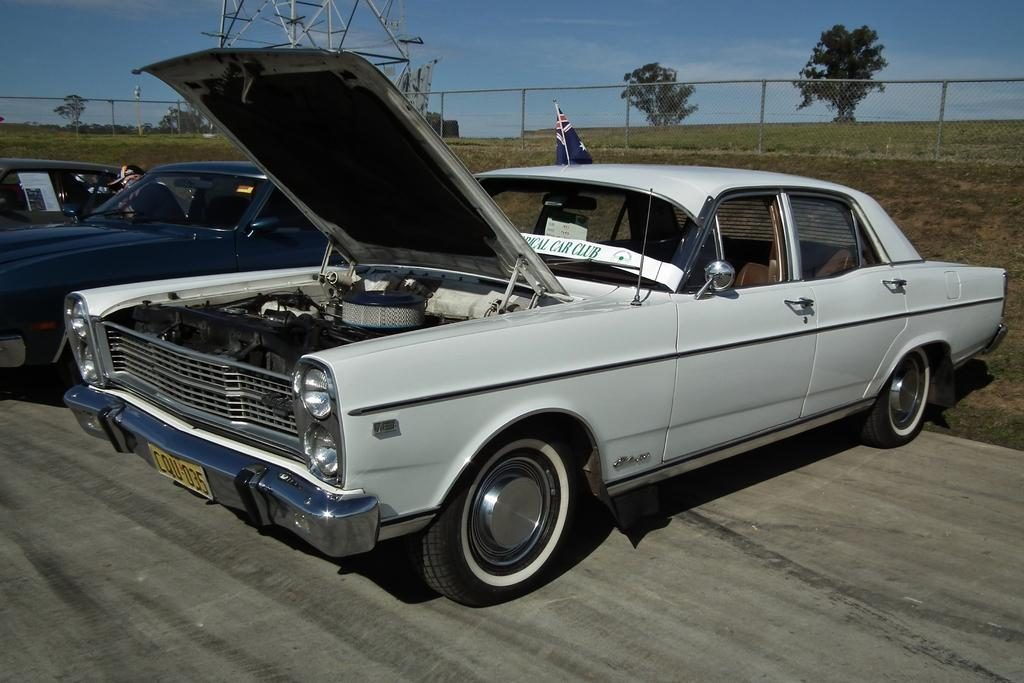What types of objects are present in the image? There are vehicles in the image. What can be seen on the ground in the background? There is grass on the ground in the background. What architectural feature is visible in the background? There is a fence in the background. What natural elements are present in the background? There are trees and a tower in the background. What is attached to the tower? There is a flag in the background. How would you describe the sky in the image? The sky is cloudy. Can you see a thumbprint on the flag in the image? There is no thumbprint visible on the flag in the image. Are there any snakes visible in the image? There are no snakes present in the image. 